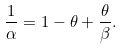<formula> <loc_0><loc_0><loc_500><loc_500>\frac { 1 } { \alpha } = 1 - \theta + \frac { \theta } { \beta } .</formula> 